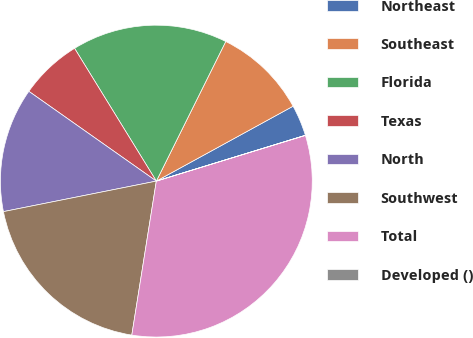Convert chart to OTSL. <chart><loc_0><loc_0><loc_500><loc_500><pie_chart><fcel>Northeast<fcel>Southeast<fcel>Florida<fcel>Texas<fcel>North<fcel>Southwest<fcel>Total<fcel>Developed ()<nl><fcel>3.23%<fcel>9.68%<fcel>16.13%<fcel>6.45%<fcel>12.9%<fcel>19.35%<fcel>32.25%<fcel>0.01%<nl></chart> 